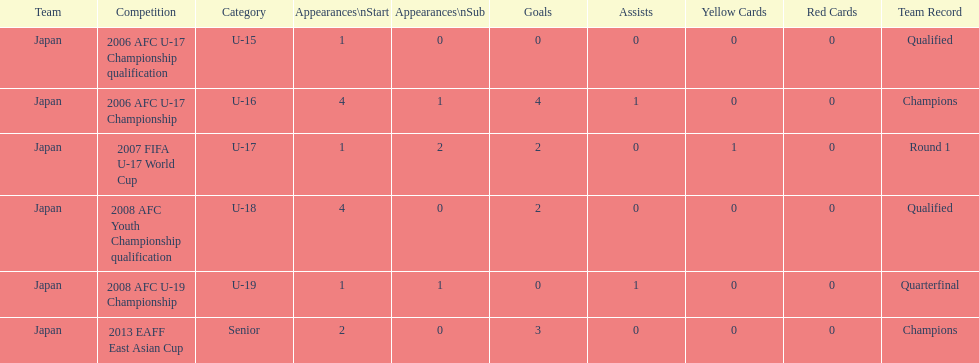Between the 2013 eaff east asian cup and the 2007 fifa u-17 world cup, which one saw japan make more starting appearances? 2013 EAFF East Asian Cup. 